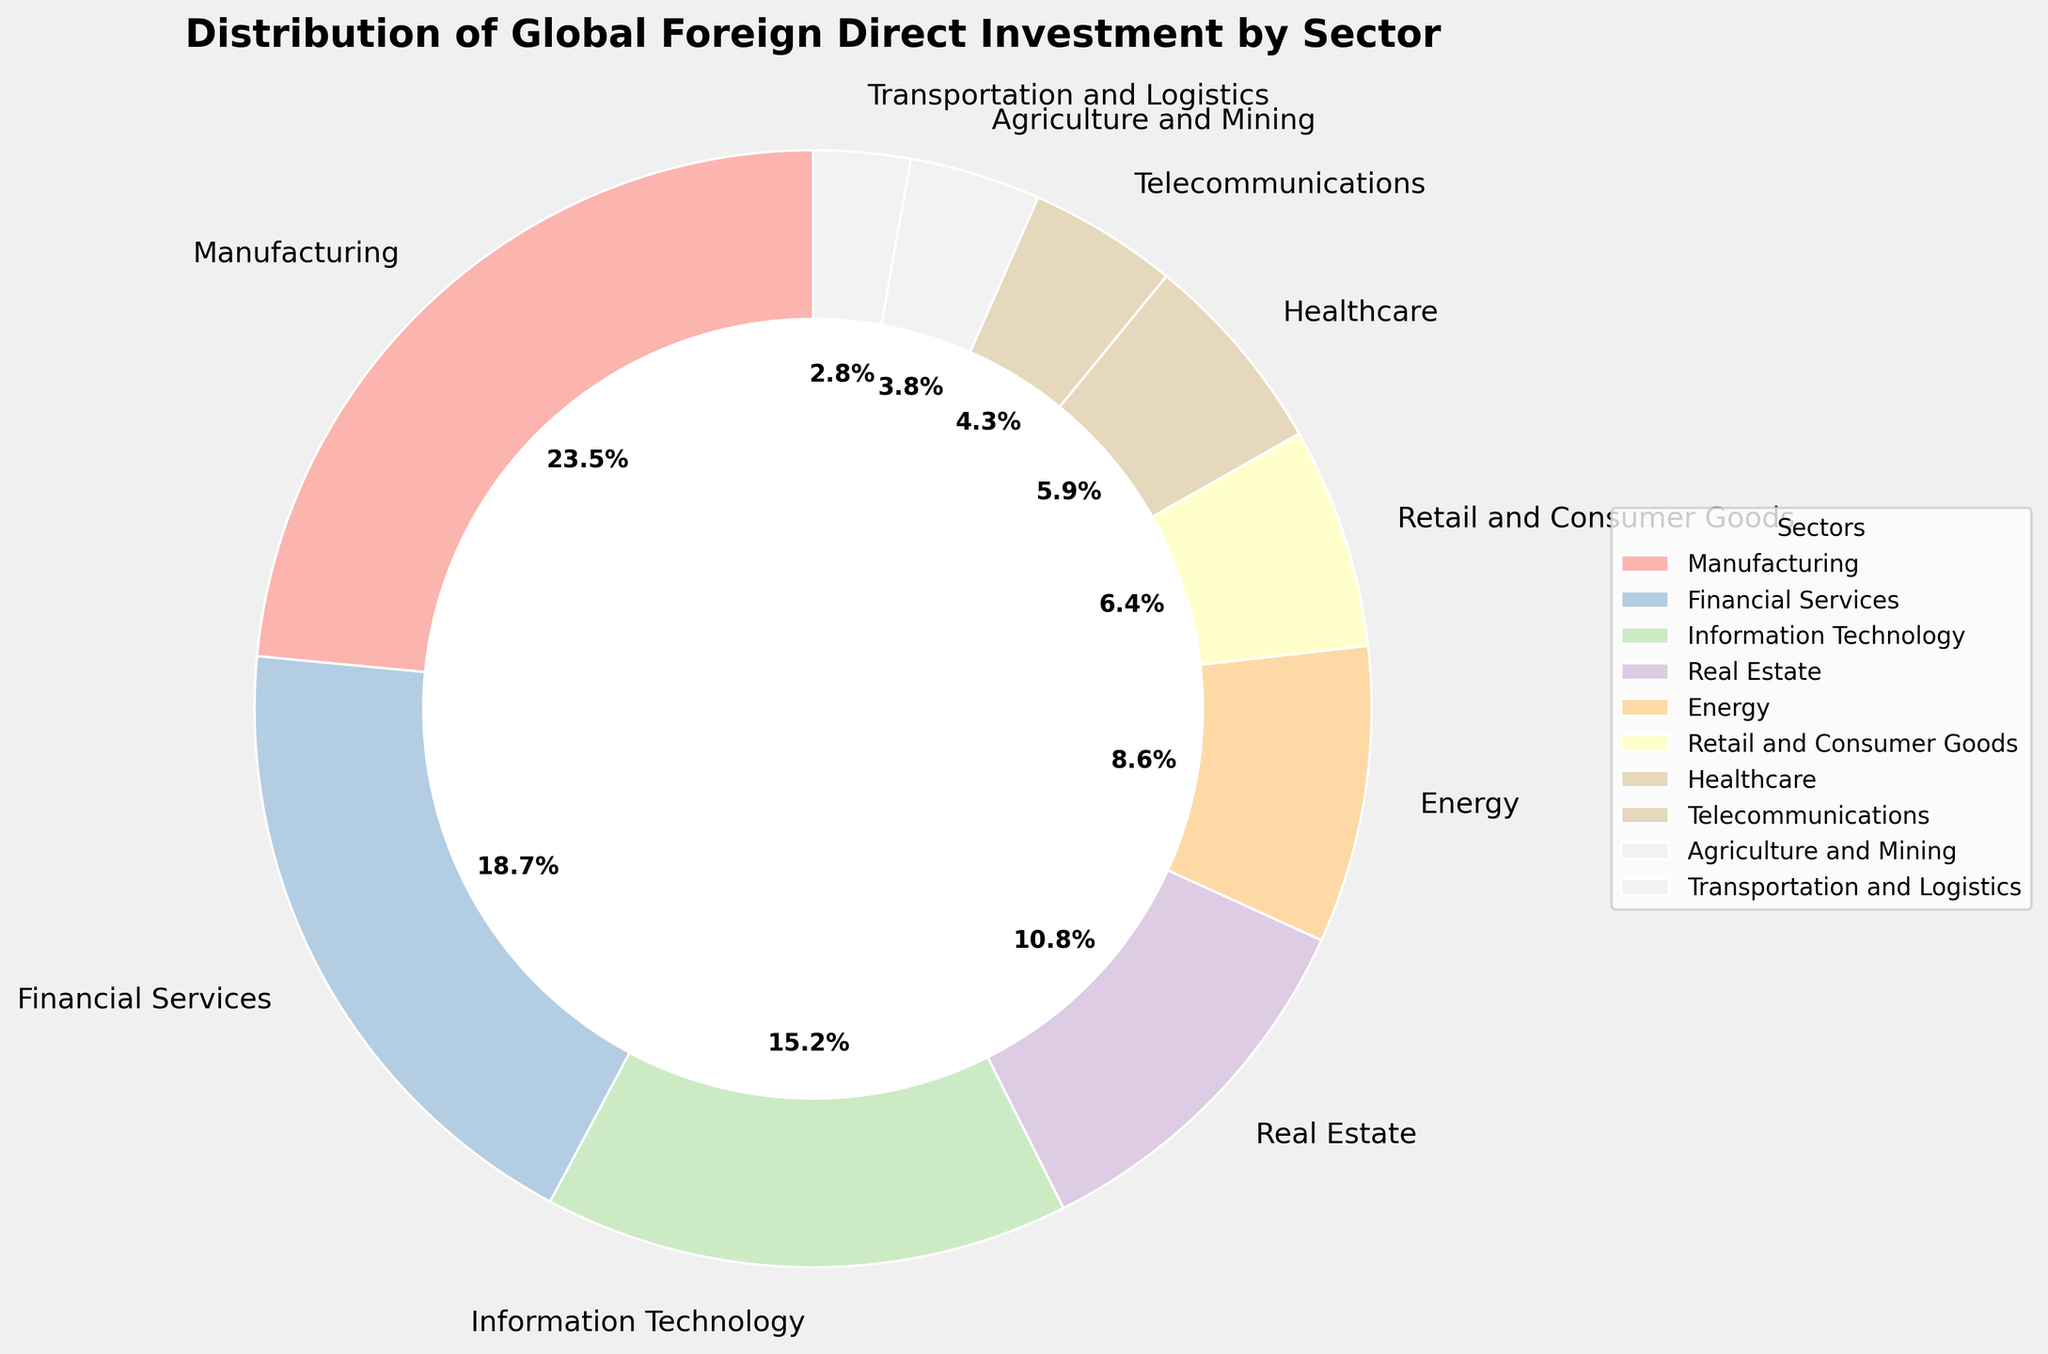Which sector received the highest percentage of global foreign direct investment? The figure shows a pie chart with sectors and their respective investment percentages. The sector with the highest percentage is Manufacturing at 23.5%.
Answer: Manufacturing Which sector has the smallest share of global foreign direct investment? Reviewing the pie chart, we see the sector with the smallest percentage is Transportation and Logistics at 2.8%.
Answer: Transportation and Logistics What is the combined percentage of global foreign direct investment in Manufacturing and Financial Services? Adding the percentages for Manufacturing (23.5%) and Financial Services (18.7%), we get 23.5 + 18.7 = 42.2%.
Answer: 42.2% Compare the investment percentages in Healthcare and Telecommunications. Which one is higher? The pie chart shows Healthcare at 5.9% and Telecommunications at 4.3%. Therefore, Healthcare is higher.
Answer: Healthcare How much more investment does the Energy sector attract compared to the Agriculture and Mining sector? The Energy sector attracts 8.6%, while Agriculture and Mining attract 3.8%. Subtracting these, 8.6 - 3.8 = 4.8%.
Answer: 4.8% Which sectors together make up more than 50% of the global foreign direct investment? Adding the highest investment percentages sequentially: Manufacturing (23.5%) and Financial Services (18.7%) together make 42.2%. Including Information Technology (15.2%) gives a sum of 57.4%. Therefore, these three sectors together make up more than 50%.
Answer: Manufacturing, Financial Services, Information Technology What percentage of global foreign direct investment is outside the top three sectors? The top three sectors are Manufacturing (23.5%), Financial Services (18.7%), and Information Technology (15.2%), together making 57.4%. Subtracting this from 100%, 100 - 57.4 = 42.6% is invested in other sectors.
Answer: 42.6% Which sector is exactly midway between the Real Estate sector and the Energy sector in terms of investment percentage? Real Estate is at 10.8%, and Energy is at 8.6%. The average of these is (10.8 + 8.6) / 2 = 9.7%. Comparing with the chart, there is no sector exactly at 9.7%, but Retail and Consumer Goods (6.4%) and Healthcare (5.9%) are the closest.
Answer: None exactly (Closest: Retail and Consumer Goods, Healthcare) How much investment does the Telecommunications sector have if the overall global investment is $2 trillion? The percentage for Telecommunications is 4.3%. Therefore, the investment is \( 4.3\% \times 2 \) trillion dollars = \( 0.043 \times 2 \) trillion = $86 billion.
Answer: $86 billion 